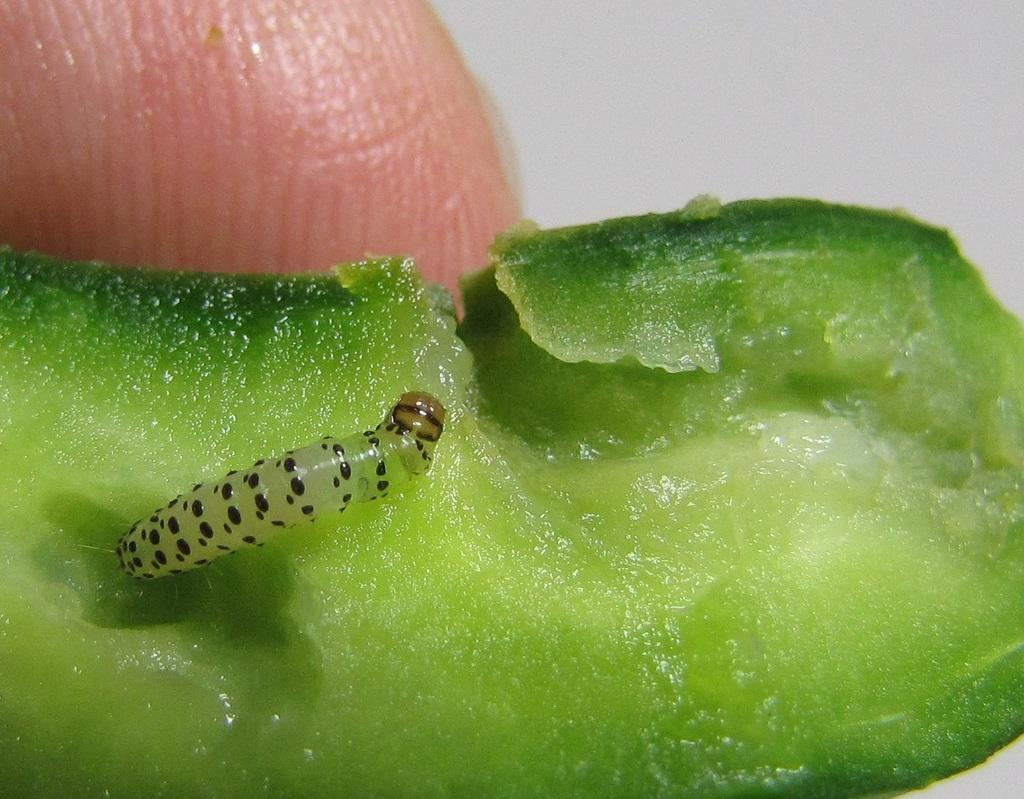What type of creature is present in the image? There is an insect in the image. Where is the insect located? The insect appears to be in a vegetable. Can you see any human body parts in the image? Yes, there is a person's finger visible at the top of the image. What type of thrill can be experienced by the insect in the image? There is no indication of any thrill experienced by the insect in the image. 